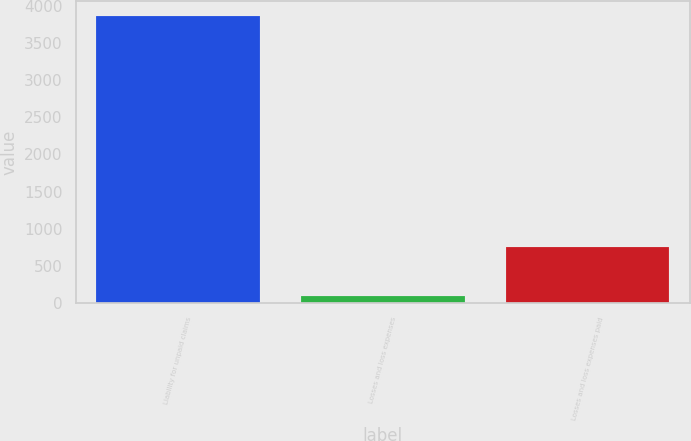Convert chart. <chart><loc_0><loc_0><loc_500><loc_500><bar_chart><fcel>Liability for unpaid claims<fcel>Losses and loss expenses<fcel>Losses and loss expenses paid<nl><fcel>3864<fcel>96<fcel>755<nl></chart> 